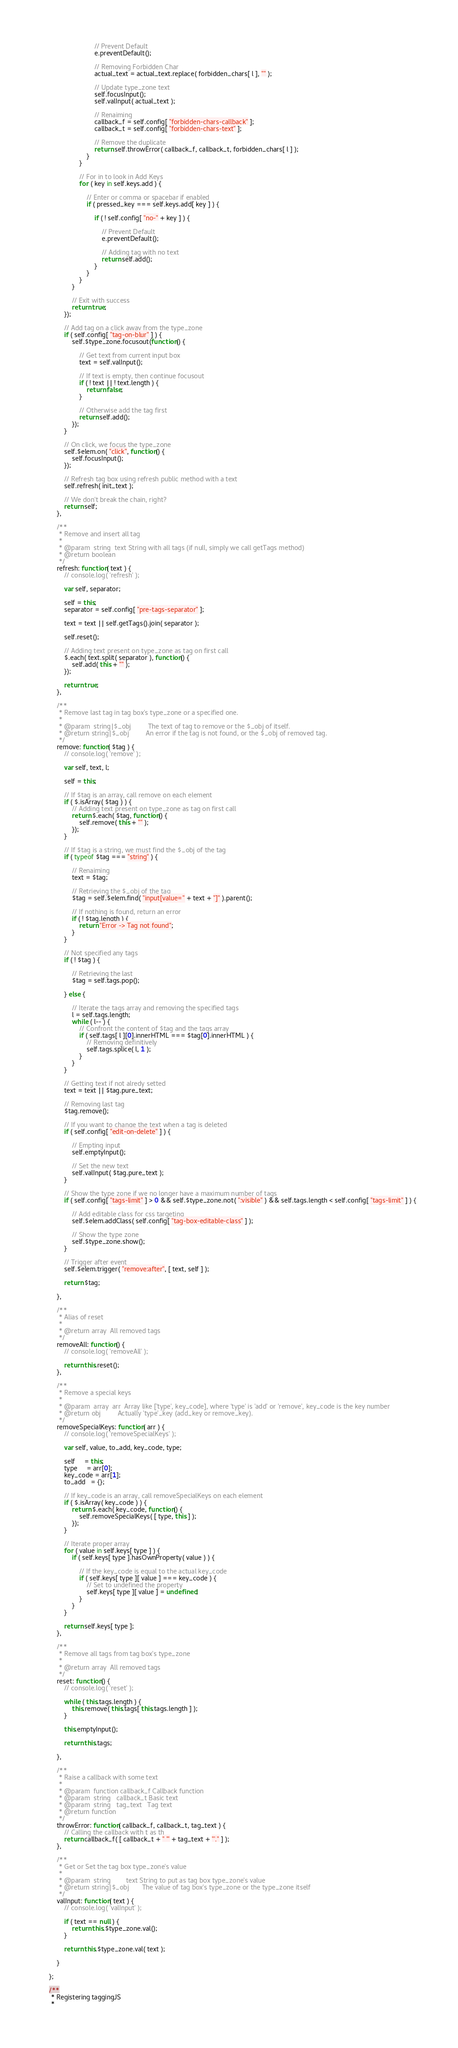Convert code to text. <code><loc_0><loc_0><loc_500><loc_500><_JavaScript_>
                            // Prevent Default
                            e.preventDefault();

                            // Removing Forbidden Char
                            actual_text = actual_text.replace( forbidden_chars[ l ], "" );

                            // Update type_zone text
                            self.focusInput();
                            self.valInput( actual_text );

                            // Renaiming
                            callback_f = self.config[ "forbidden-chars-callback" ];
                            callback_t = self.config[ "forbidden-chars-text" ];

                            // Remove the duplicate
                            return self.throwError( callback_f, callback_t, forbidden_chars[ l ] );
                        }
                    }

                    // For in to look in Add Keys
                    for ( key in self.keys.add ) {

                        // Enter or comma or spacebar if enabled
                        if ( pressed_key === self.keys.add[ key ] ) {

                            if ( ! self.config[ "no-" + key ] ) {

                                // Prevent Default
                                e.preventDefault();

                                // Adding tag with no text
                                return self.add();
                            }
                        }
                    }
                }

                // Exit with success
                return true;
            });

            // Add tag on a click away from the type_zone
            if ( self.config[ "tag-on-blur" ] ) {
                self.$type_zone.focusout(function() {

                    // Get text from current input box
                    text = self.valInput();

                    // If text is empty, then continue focusout
                    if ( ! text || ! text.length ) {
                        return false;
                    }

                    // Otherwise add the tag first
                    return self.add();
                });
            }

            // On click, we focus the type_zone
            self.$elem.on( "click", function() {
                self.focusInput();
            });

            // Refresh tag box using refresh public method with a text
            self.refresh( init_text );

            // We don't break the chain, right?
            return self;
        },

        /**
         * Remove and insert all tag
         *
         * @param  string  text String with all tags (if null, simply we call getTags method)
         * @return boolean
         */
        refresh: function( text ) {
            // console.log( 'refresh' );

            var self, separator;

            self = this;
            separator = self.config[ "pre-tags-separator" ];

            text = text || self.getTags().join( separator );

            self.reset();

            // Adding text present on type_zone as tag on first call
            $.each( text.split( separator ), function() {
                self.add( this + "" );
            });

            return true;
        },

        /**
         * Remove last tag in tag box's type_zone or a specified one.
         *
         * @param  string|$_obj         The text of tag to remove or the $_obj of itself.
         * @return string|$_obj         An error if the tag is not found, or the $_obj of removed tag.
         */
        remove: function( $tag ) {
            // console.log( 'remove' );

            var self, text, l;

            self = this;

            // If $tag is an array, call remove on each element
            if ( $.isArray( $tag ) ) {
                // Adding text present on type_zone as tag on first call
                return $.each( $tag, function() {
                    self.remove( this + "" );
                });
            }

            // If $tag is a string, we must find the $_obj of the tag
            if ( typeof $tag === "string" ) {

                // Renaiming
                text = $tag;

                // Retrieving the $_obj of the tag
                $tag = self.$elem.find( "input[value=" + text + "]" ).parent();

                // If nothing is found, return an error
                if ( ! $tag.length ) {
                    return "Error -> Tag not found";
                }
            }

            // Not specified any tags
            if ( ! $tag ) {

                // Retrieving the last
                $tag = self.tags.pop();

            } else {

                // Iterate the tags array and removing the specified tags
                l = self.tags.length;
                while ( l-- ) {
                    // Confront the content of $tag and the tags array
                    if ( self.tags[ l ][0].innerHTML === $tag[0].innerHTML ) {
                        // Removing definitively
                        self.tags.splice( l, 1 );
                    }
                }
            }

            // Getting text if not alredy setted
            text = text || $tag.pure_text;

            // Removing last tag
            $tag.remove();

            // If you want to change the text when a tag is deleted
            if ( self.config[ "edit-on-delete" ] ) {

                // Empting input
                self.emptyInput();

                // Set the new text
                self.valInput( $tag.pure_text );
            }

            // Show the type zone if we no longer have a maximum number of tags
            if ( self.config[ "tags-limit" ] > 0 && self.$type_zone.not( ":visible" ) && self.tags.length < self.config[ "tags-limit" ] ) {

                // Add editable class for css targeting
                self.$elem.addClass( self.config[ "tag-box-editable-class" ] );

                // Show the type zone
                self.$type_zone.show();
            }

            // Trigger after event
            self.$elem.trigger( "remove:after", [ text, self ] );

            return $tag;

        },

        /**
         * Alias of reset
         *
         * @return array  All removed tags
         */
        removeAll: function() {
            // console.log( 'removeAll' );

            return this.reset();
        },

        /**
         * Remove a special keys
         *
         * @param  array  arr  Array like ['type', key_code], where 'type' is 'add' or 'remove', key_code is the key number
         * @return obj         Actually 'type'_key (add_key or remove_key).
         */
        removeSpecialKeys: function( arr ) {
            // console.log( 'removeSpecialKeys' );

            var self, value, to_add, key_code, type;

            self     = this;
            type     = arr[0];
            key_code = arr[1];
            to_add   = {};

            // If key_code is an array, call removeSpecialKeys on each element
            if ( $.isArray( key_code ) ) {
                return $.each( key_code, function() {
                    self.removeSpecialKeys( [ type, this ] );
                });
            }

            // Iterate proper array
            for ( value in self.keys[ type ] ) {
                if ( self.keys[ type ].hasOwnProperty( value ) ) {

                    // If the key_code is equal to the actual key_code
                    if ( self.keys[ type ][ value ] === key_code ) {
                        // Set to undefined the property
                        self.keys[ type ][ value ] = undefined;
                    }
                }
            }

            return self.keys[ type ];
        },

        /**
         * Remove all tags from tag box's type_zone
         *
         * @return array  All removed tags
         */
        reset: function() {
            // console.log( 'reset' );

            while ( this.tags.length ) {
                this.remove( this.tags[ this.tags.length ] );
            }

            this.emptyInput();

            return this.tags;

        },

        /**
         * Raise a callback with some text
         *
         * @param  function callback_f Callback function
         * @param  string   callback_t Basic text
         * @param  string   tag_text   Tag text
         * @return function
         */
        throwError: function( callback_f, callback_t, tag_text ) {
            // Calling the callback with t as th
            return callback_f( [ callback_t + " '" + tag_text + "'." ] );
        },

        /**
         * Get or Set the tag box type_zone's value
         *
         * @param  string        text String to put as tag box type_zone's value
         * @return string|$_obj       The value of tag box's type_zone or the type_zone itself
         */
        valInput: function( text ) {
            // console.log( 'valInput' );

            if ( text == null ) {
                return this.$type_zone.val();
            }

            return this.$type_zone.val( text );

        }

    };

    /**
     * Registering taggingJS
     *</code> 